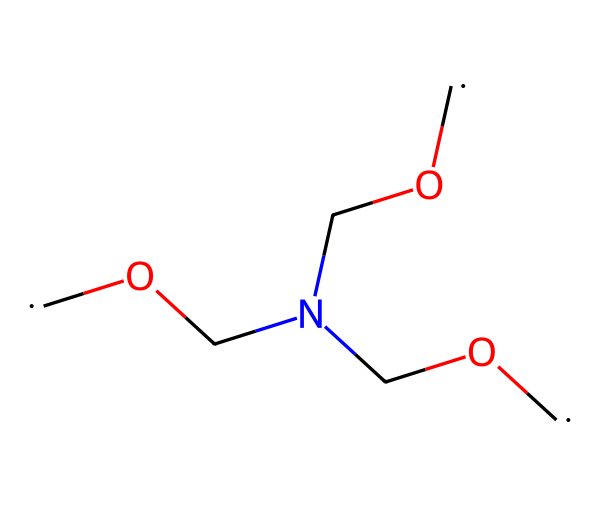What is the total number of carbon atoms in the chemical? By examining the SMILES representation, we can identify that there are four occurrences of the carbon fragment [CH2]. Therefore, there are four carbon atoms in total.
Answer: four How many oxygen atoms are present in this chemical? The chemical structure shows three occurrences of the oxygen atom as -O-. Counting these occurrences, we find three oxygen atoms.
Answer: three What type of bonding is most likely between carbon and oxygen in this structure? In a structure comprising C-O connections, the bonding is predominantly polar covalent due to the difference in electronegativity between carbon and oxygen.
Answer: polar covalent Which group is responsible for the chemical's formaldehyde-based nature? The presence of the -O- (hydroxymethyl) groups indicates that formaldehyde units are present within the molecular structure, connecting the carbon atoms.
Answer: -O- What is the connectivity pattern of this chemical in terms of carbon, oxygen, and nitrogen? The connections can be traced as a linear arrangement of carbons and alternating oxygens with a nitrogen atom linking two hydroxymethyl groups, showing a branched structure due to nitrogen's position.
Answer: linear and branched How does the presence of nitrogen affect the resin's properties? Nitrogen introduces cross-linking potential in the resin, enhancing mechanical properties and thermal stability, which contributes to its structural integrity.
Answer: cross-linking What is the most probable use of formaldehyde-based resins in property development? Given their adhesive properties and durability, they are commonly used in manufacturing plywood and particleboard, essential materials in construction.
Answer: construction materials 